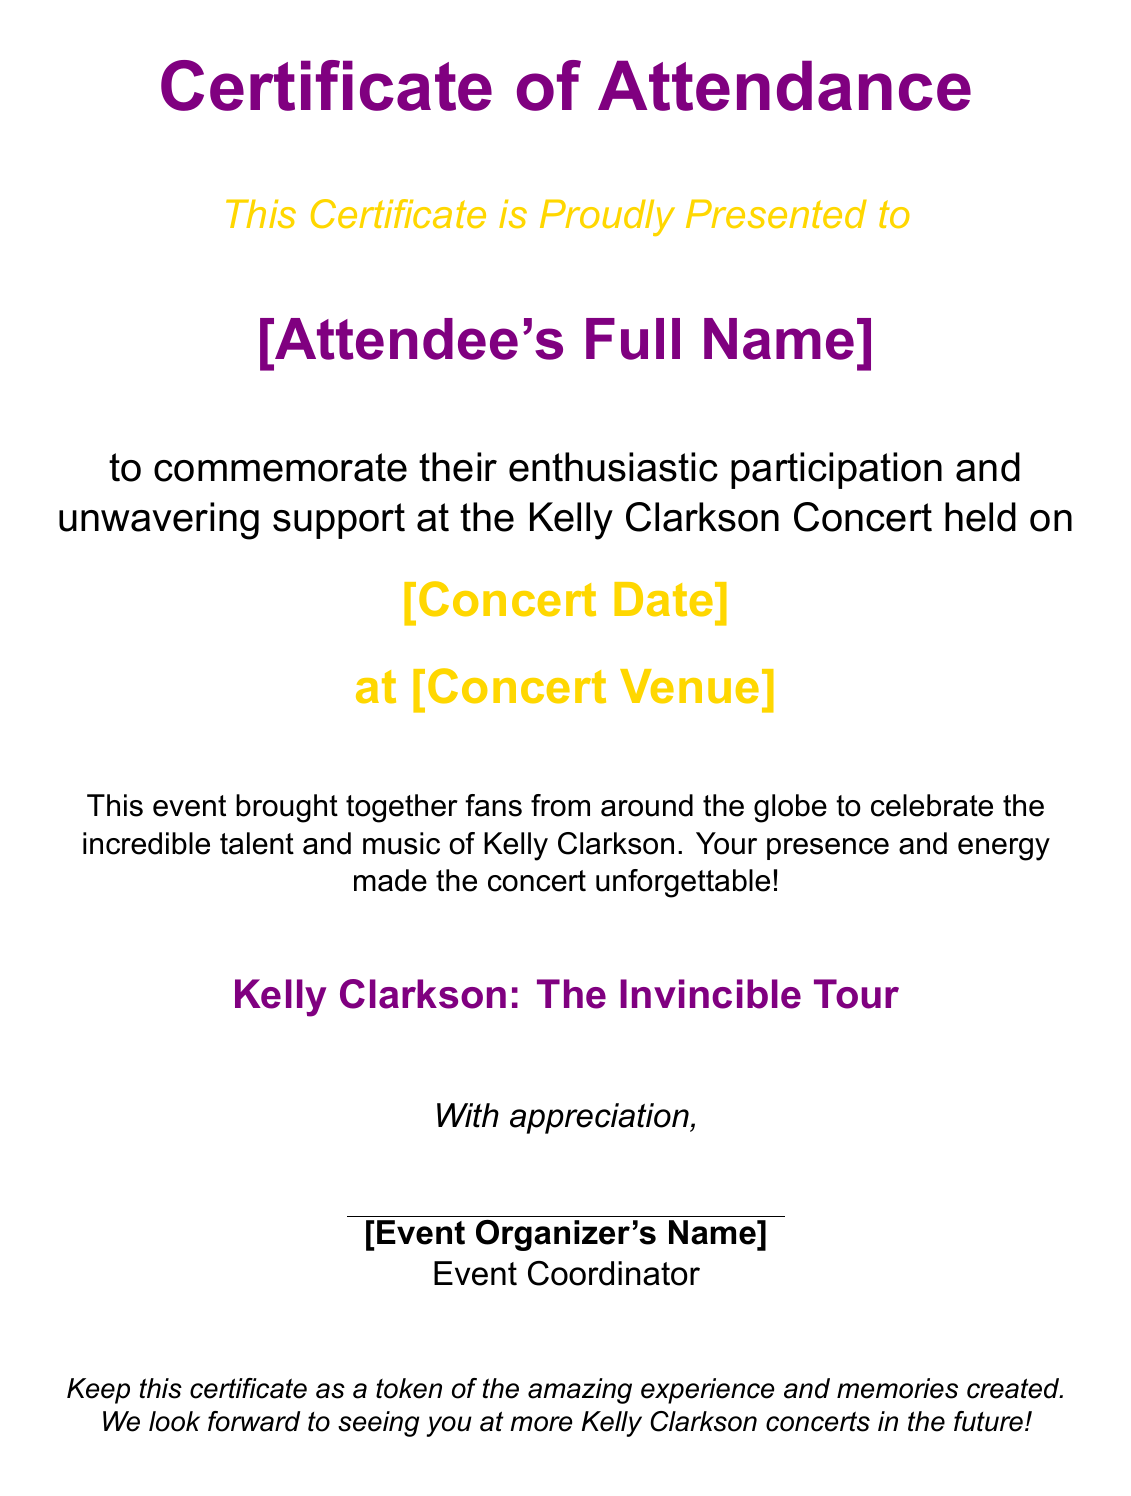What is the title of the document? The title of the document is shown prominently at the top, identifying it as a certificate of attendance.
Answer: Certificate of Attendance Who is this certificate presented to? The document specifies that the certificate is presented to the attendee, who is mentioned in a placeholder text.
Answer: [Attendee's Full Name] What date is the concert held on? The document includes a section dedicated to the concert date, which needs to be specified.
Answer: [Concert Date] Where did the concert take place? This information is found in a designated section of the certificate, indicating the venue for the concert.
Answer: [Concert Venue] Who signed the certificate? The document concludes with the name of the event organizer, mentioned as part of the certificate.
Answer: [Event Organizer's Name] What tour is associated with this certificate? The last prominent section of the document mentions the tour related to Kelly Clarkson.
Answer: The Invincible Tour What color is the certificate's title text? The title text is highlighted in a specific color throughout the document.
Answer: Kelly purple What is the purpose of this certificate? The document explains the reason for its issuance, focusing on participation and support at the concert.
Answer: To commemorate participation What message does the certificate convey about the concert? The document reflects on the experience and energy shared during the concert.
Answer: Unforgettable 